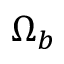<formula> <loc_0><loc_0><loc_500><loc_500>\Omega _ { b }</formula> 